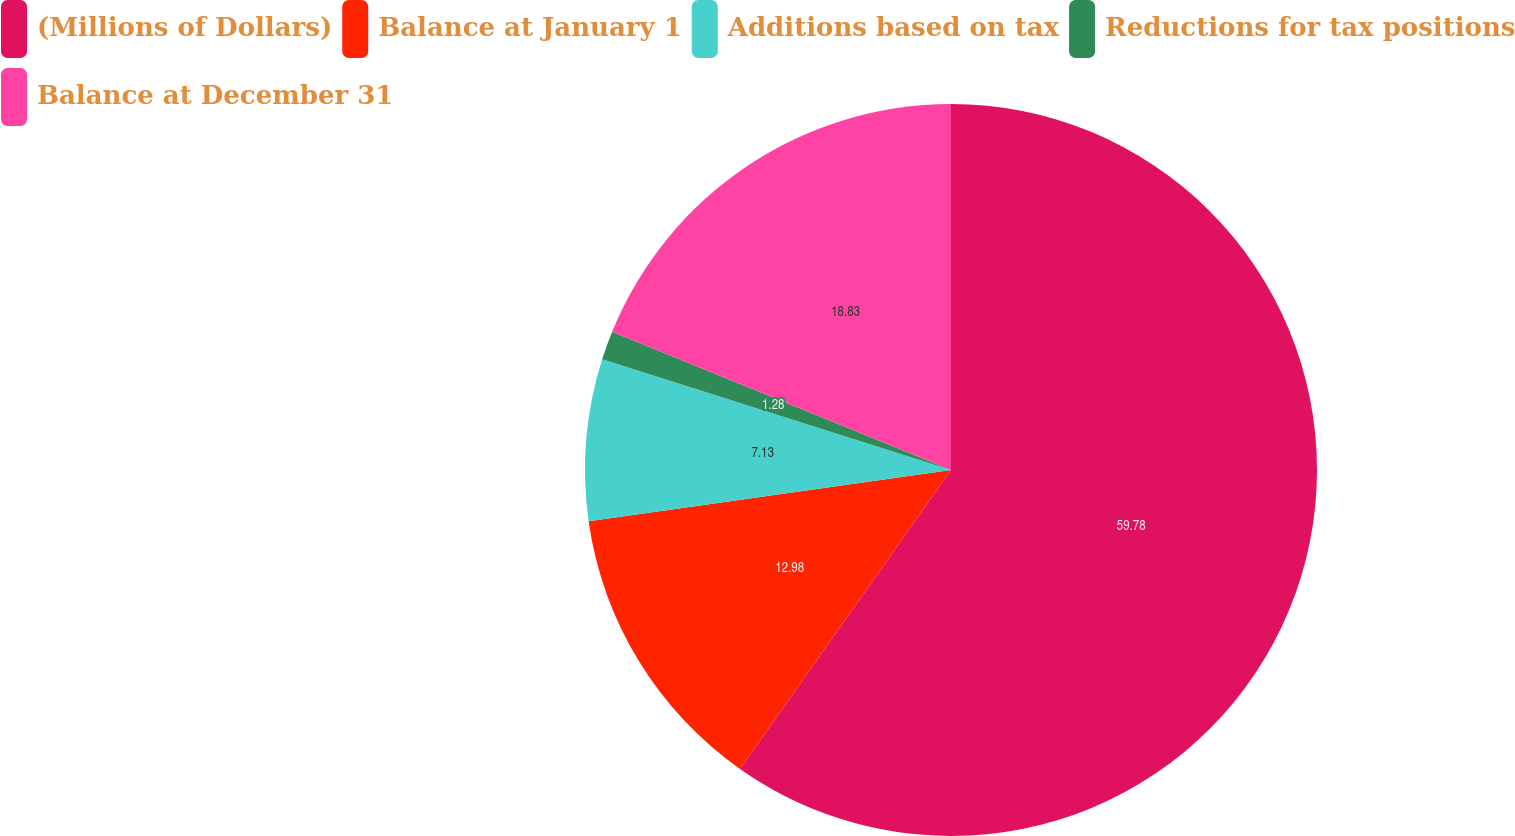Convert chart to OTSL. <chart><loc_0><loc_0><loc_500><loc_500><pie_chart><fcel>(Millions of Dollars)<fcel>Balance at January 1<fcel>Additions based on tax<fcel>Reductions for tax positions<fcel>Balance at December 31<nl><fcel>59.78%<fcel>12.98%<fcel>7.13%<fcel>1.28%<fcel>18.83%<nl></chart> 